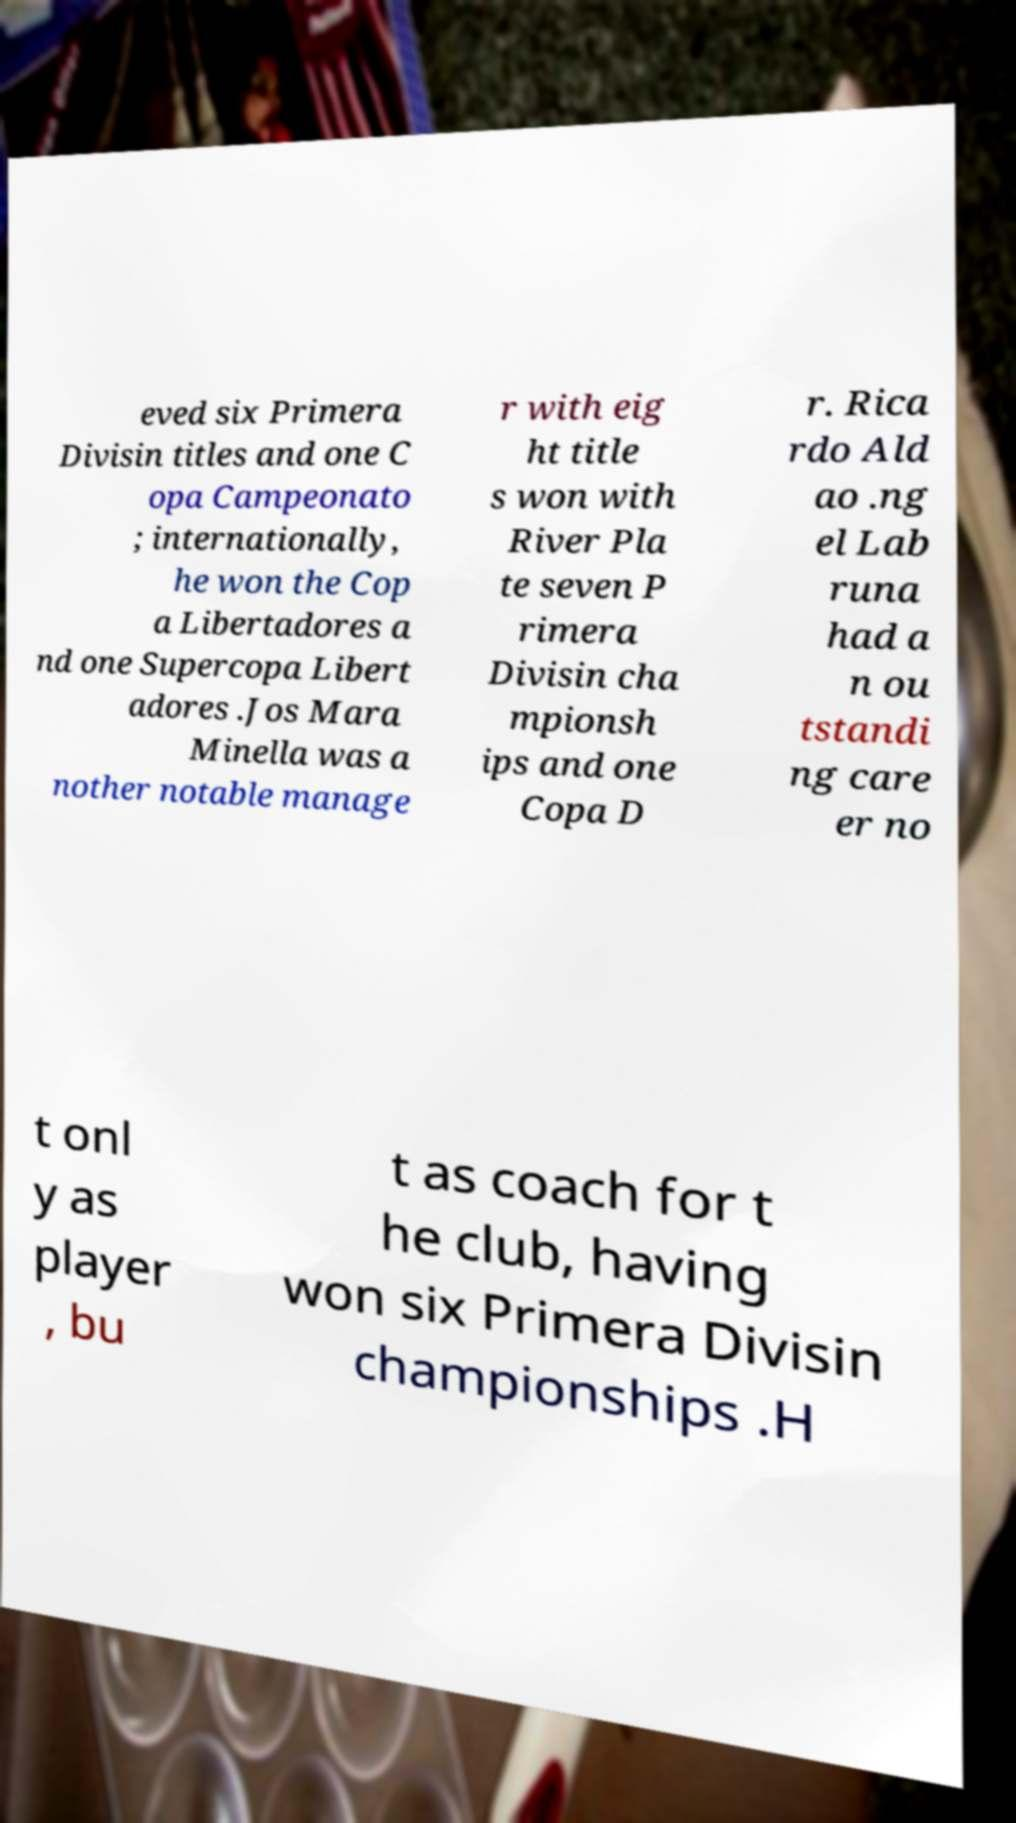Could you assist in decoding the text presented in this image and type it out clearly? eved six Primera Divisin titles and one C opa Campeonato ; internationally, he won the Cop a Libertadores a nd one Supercopa Libert adores .Jos Mara Minella was a nother notable manage r with eig ht title s won with River Pla te seven P rimera Divisin cha mpionsh ips and one Copa D r. Rica rdo Ald ao .ng el Lab runa had a n ou tstandi ng care er no t onl y as player , bu t as coach for t he club, having won six Primera Divisin championships .H 